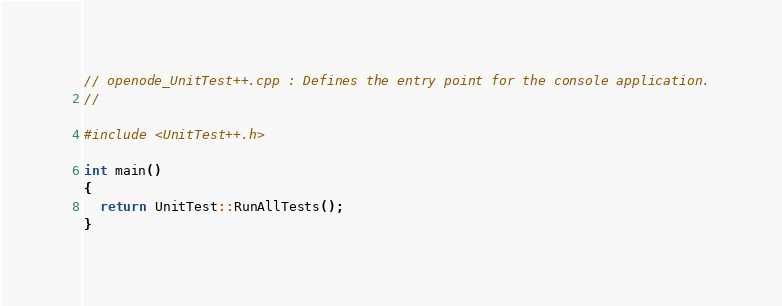<code> <loc_0><loc_0><loc_500><loc_500><_C++_>// openode_UnitTest++.cpp : Defines the entry point for the console application.
//

#include <UnitTest++.h>

int main()
{
  return UnitTest::RunAllTests();
}
</code> 